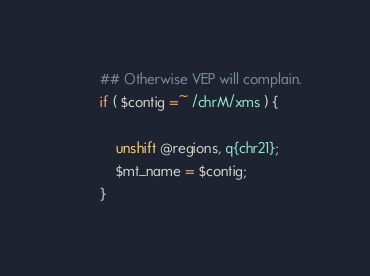<code> <loc_0><loc_0><loc_500><loc_500><_Perl_>        ## Otherwise VEP will complain.
        if ( $contig =~ /chrM/xms ) {

            unshift @regions, q{chr21};
            $mt_name = $contig;
        }</code> 